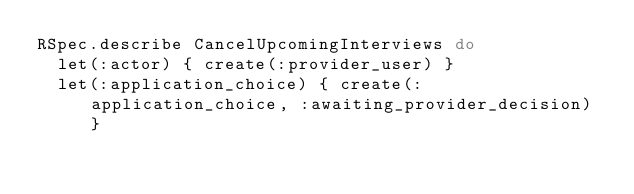<code> <loc_0><loc_0><loc_500><loc_500><_Ruby_>RSpec.describe CancelUpcomingInterviews do
  let(:actor) { create(:provider_user) }
  let(:application_choice) { create(:application_choice, :awaiting_provider_decision) }</code> 